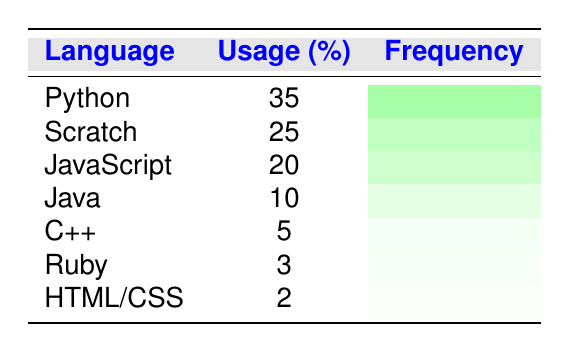What programming language has the highest usage percentage among school-aged children? The table lists the programming languages along with their usage percentages. By looking at the "Usage (%)" column, we can see that Python has the highest usage percentage at 35%.
Answer: Python What percentage of school-aged children use JavaScript? The table indicates that the usage percentage for JavaScript is listed directly in the "Usage (%)" column, which shows 20%.
Answer: 20% Is the usage percentage of C++ greater than that of Ruby? By comparing the usage percentages from the table, C++ has a usage percentage of 5% and Ruby has 3%. Since 5% is greater than 3%, this statement is true.
Answer: Yes What is the total percentage usage of the top three programming languages? The top three programming languages based on usage percentages are Python (35%), Scratch (25%), and JavaScript (20%). We can add these values: 35 + 25 + 20 = 80%.
Answer: 80% What language has the least usage among school-aged children in this data? By examining the "Usage (%)" column, the lowest percentage is for HTML/CSS, which has a usage percentage of 2%.
Answer: HTML/CSS If we combine the usage percentages of Ruby and HTML/CSS, what do we get? Ruby has a usage percentage of 3% and HTML/CSS has 2%. When we add these together: 3 + 2 = 5%.
Answer: 5% Does the combined usage percentage of Python and Java exceed 40%? The percentage of Python is 35% and of Java is 10%. Adding these together: 35 + 10 = 45%. Therefore, it does exceed 40%.
Answer: Yes What percentage of children use a programming language that is not among the top three? The top three programming languages are Python (35%), Scratch (25%), and JavaScript (20%). The combined usage of these three languages is 80%, so the percentage that uses others is 100% - 80% = 20%.
Answer: 20% How does the usage percentage of Scratch compare to that of C++? Scratch has a usage percentage of 25% while C++ has 5%. When compared, Scratch's usage percentage is significantly higher than C++.
Answer: Scratch is higher 